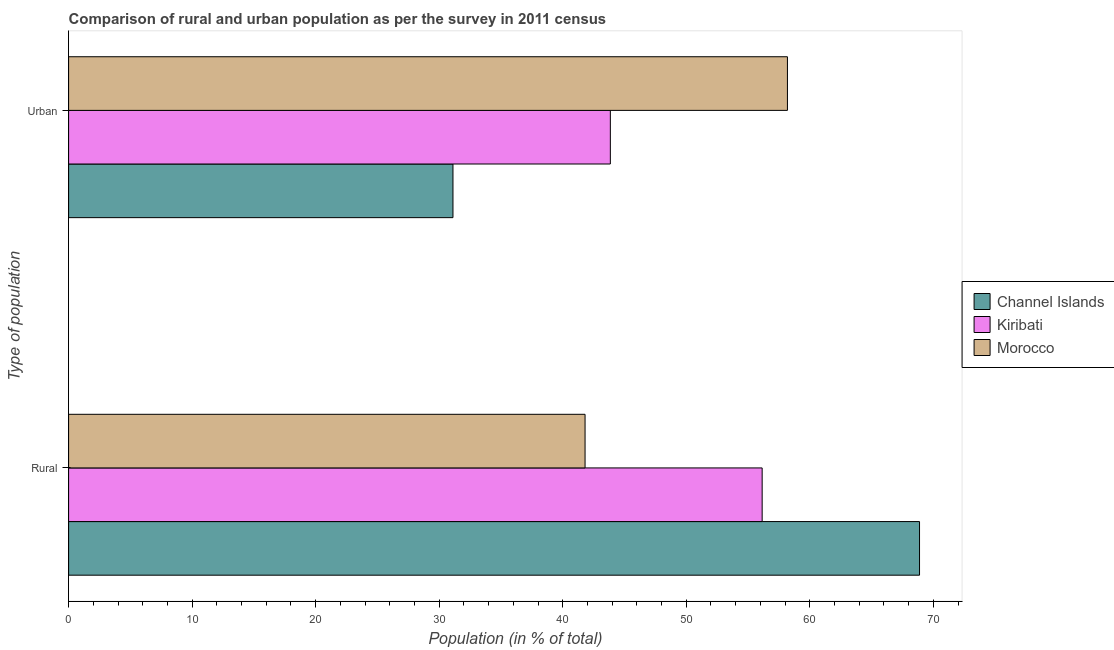How many different coloured bars are there?
Ensure brevity in your answer.  3. Are the number of bars on each tick of the Y-axis equal?
Provide a succinct answer. Yes. How many bars are there on the 1st tick from the top?
Your response must be concise. 3. How many bars are there on the 2nd tick from the bottom?
Your answer should be compact. 3. What is the label of the 1st group of bars from the top?
Offer a terse response. Urban. What is the rural population in Morocco?
Offer a terse response. 41.81. Across all countries, what is the maximum rural population?
Give a very brief answer. 68.88. Across all countries, what is the minimum urban population?
Your answer should be very brief. 31.12. In which country was the rural population maximum?
Provide a short and direct response. Channel Islands. In which country was the urban population minimum?
Your answer should be very brief. Channel Islands. What is the total urban population in the graph?
Provide a succinct answer. 133.16. What is the difference between the urban population in Morocco and that in Kiribati?
Ensure brevity in your answer.  14.34. What is the difference between the rural population in Morocco and the urban population in Kiribati?
Ensure brevity in your answer.  -2.05. What is the average urban population per country?
Your response must be concise. 44.39. What is the difference between the urban population and rural population in Kiribati?
Provide a short and direct response. -12.29. In how many countries, is the urban population greater than 38 %?
Provide a short and direct response. 2. What is the ratio of the urban population in Kiribati to that in Channel Islands?
Your response must be concise. 1.41. What does the 3rd bar from the top in Rural represents?
Provide a short and direct response. Channel Islands. What does the 1st bar from the bottom in Rural represents?
Your answer should be compact. Channel Islands. How many bars are there?
Offer a terse response. 6. Are all the bars in the graph horizontal?
Offer a terse response. Yes. Does the graph contain any zero values?
Offer a terse response. No. Does the graph contain grids?
Provide a succinct answer. No. Where does the legend appear in the graph?
Give a very brief answer. Center right. How many legend labels are there?
Give a very brief answer. 3. What is the title of the graph?
Keep it short and to the point. Comparison of rural and urban population as per the survey in 2011 census. Does "Uruguay" appear as one of the legend labels in the graph?
Your response must be concise. No. What is the label or title of the X-axis?
Ensure brevity in your answer.  Population (in % of total). What is the label or title of the Y-axis?
Your answer should be compact. Type of population. What is the Population (in % of total) in Channel Islands in Rural?
Your answer should be very brief. 68.88. What is the Population (in % of total) of Kiribati in Rural?
Your answer should be very brief. 56.15. What is the Population (in % of total) in Morocco in Rural?
Offer a terse response. 41.81. What is the Population (in % of total) of Channel Islands in Urban?
Make the answer very short. 31.12. What is the Population (in % of total) in Kiribati in Urban?
Keep it short and to the point. 43.85. What is the Population (in % of total) of Morocco in Urban?
Offer a very short reply. 58.19. Across all Type of population, what is the maximum Population (in % of total) of Channel Islands?
Your answer should be compact. 68.88. Across all Type of population, what is the maximum Population (in % of total) in Kiribati?
Your response must be concise. 56.15. Across all Type of population, what is the maximum Population (in % of total) of Morocco?
Ensure brevity in your answer.  58.19. Across all Type of population, what is the minimum Population (in % of total) in Channel Islands?
Give a very brief answer. 31.12. Across all Type of population, what is the minimum Population (in % of total) of Kiribati?
Give a very brief answer. 43.85. Across all Type of population, what is the minimum Population (in % of total) in Morocco?
Provide a short and direct response. 41.81. What is the total Population (in % of total) in Channel Islands in the graph?
Provide a short and direct response. 100. What is the total Population (in % of total) of Kiribati in the graph?
Provide a short and direct response. 100. What is the total Population (in % of total) of Morocco in the graph?
Ensure brevity in your answer.  100. What is the difference between the Population (in % of total) in Channel Islands in Rural and that in Urban?
Your answer should be compact. 37.77. What is the difference between the Population (in % of total) of Kiribati in Rural and that in Urban?
Offer a very short reply. 12.29. What is the difference between the Population (in % of total) of Morocco in Rural and that in Urban?
Ensure brevity in your answer.  -16.38. What is the difference between the Population (in % of total) in Channel Islands in Rural and the Population (in % of total) in Kiribati in Urban?
Give a very brief answer. 25.03. What is the difference between the Population (in % of total) of Channel Islands in Rural and the Population (in % of total) of Morocco in Urban?
Ensure brevity in your answer.  10.69. What is the difference between the Population (in % of total) in Kiribati in Rural and the Population (in % of total) in Morocco in Urban?
Ensure brevity in your answer.  -2.05. What is the average Population (in % of total) of Channel Islands per Type of population?
Give a very brief answer. 50. What is the average Population (in % of total) of Morocco per Type of population?
Give a very brief answer. 50. What is the difference between the Population (in % of total) in Channel Islands and Population (in % of total) in Kiribati in Rural?
Give a very brief answer. 12.74. What is the difference between the Population (in % of total) of Channel Islands and Population (in % of total) of Morocco in Rural?
Make the answer very short. 27.07. What is the difference between the Population (in % of total) in Kiribati and Population (in % of total) in Morocco in Rural?
Make the answer very short. 14.34. What is the difference between the Population (in % of total) of Channel Islands and Population (in % of total) of Kiribati in Urban?
Your response must be concise. -12.74. What is the difference between the Population (in % of total) of Channel Islands and Population (in % of total) of Morocco in Urban?
Offer a terse response. -27.07. What is the difference between the Population (in % of total) of Kiribati and Population (in % of total) of Morocco in Urban?
Provide a succinct answer. -14.34. What is the ratio of the Population (in % of total) of Channel Islands in Rural to that in Urban?
Your answer should be compact. 2.21. What is the ratio of the Population (in % of total) in Kiribati in Rural to that in Urban?
Ensure brevity in your answer.  1.28. What is the ratio of the Population (in % of total) in Morocco in Rural to that in Urban?
Offer a very short reply. 0.72. What is the difference between the highest and the second highest Population (in % of total) of Channel Islands?
Your response must be concise. 37.77. What is the difference between the highest and the second highest Population (in % of total) in Kiribati?
Give a very brief answer. 12.29. What is the difference between the highest and the second highest Population (in % of total) in Morocco?
Provide a succinct answer. 16.38. What is the difference between the highest and the lowest Population (in % of total) of Channel Islands?
Ensure brevity in your answer.  37.77. What is the difference between the highest and the lowest Population (in % of total) of Kiribati?
Ensure brevity in your answer.  12.29. What is the difference between the highest and the lowest Population (in % of total) in Morocco?
Your response must be concise. 16.38. 